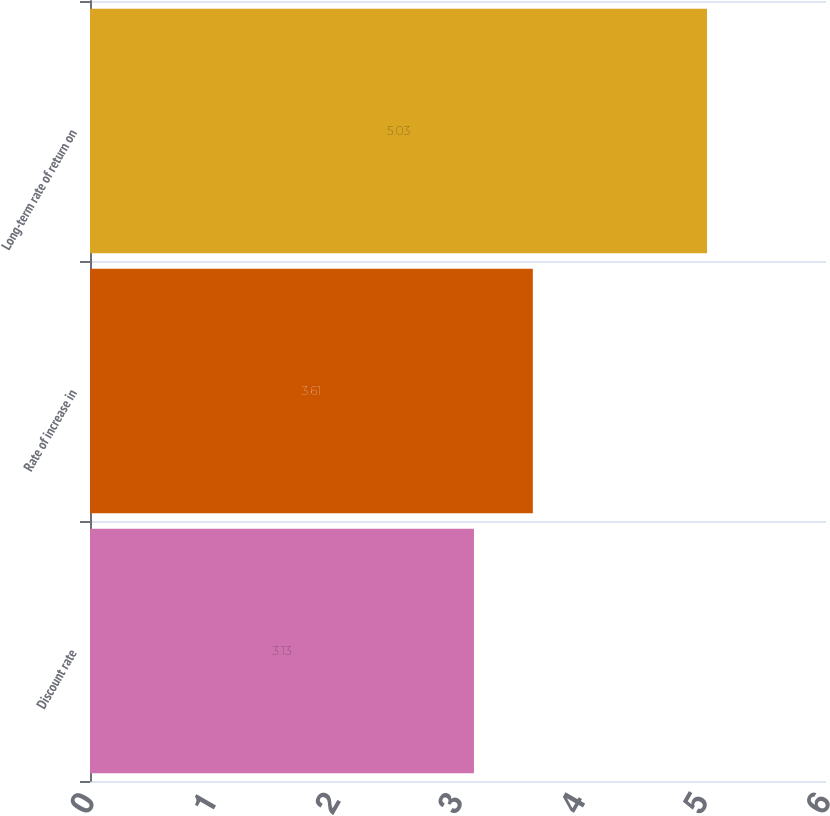<chart> <loc_0><loc_0><loc_500><loc_500><bar_chart><fcel>Discount rate<fcel>Rate of increase in<fcel>Long-term rate of return on<nl><fcel>3.13<fcel>3.61<fcel>5.03<nl></chart> 